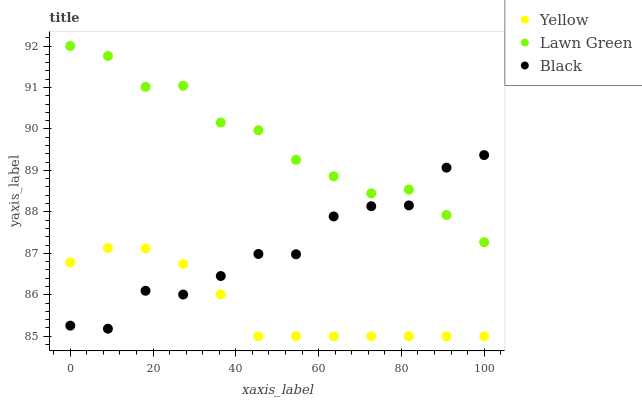Does Yellow have the minimum area under the curve?
Answer yes or no. Yes. Does Lawn Green have the maximum area under the curve?
Answer yes or no. Yes. Does Black have the minimum area under the curve?
Answer yes or no. No. Does Black have the maximum area under the curve?
Answer yes or no. No. Is Yellow the smoothest?
Answer yes or no. Yes. Is Black the roughest?
Answer yes or no. Yes. Is Black the smoothest?
Answer yes or no. No. Is Yellow the roughest?
Answer yes or no. No. Does Yellow have the lowest value?
Answer yes or no. Yes. Does Black have the lowest value?
Answer yes or no. No. Does Lawn Green have the highest value?
Answer yes or no. Yes. Does Black have the highest value?
Answer yes or no. No. Is Yellow less than Lawn Green?
Answer yes or no. Yes. Is Lawn Green greater than Yellow?
Answer yes or no. Yes. Does Black intersect Lawn Green?
Answer yes or no. Yes. Is Black less than Lawn Green?
Answer yes or no. No. Is Black greater than Lawn Green?
Answer yes or no. No. Does Yellow intersect Lawn Green?
Answer yes or no. No. 